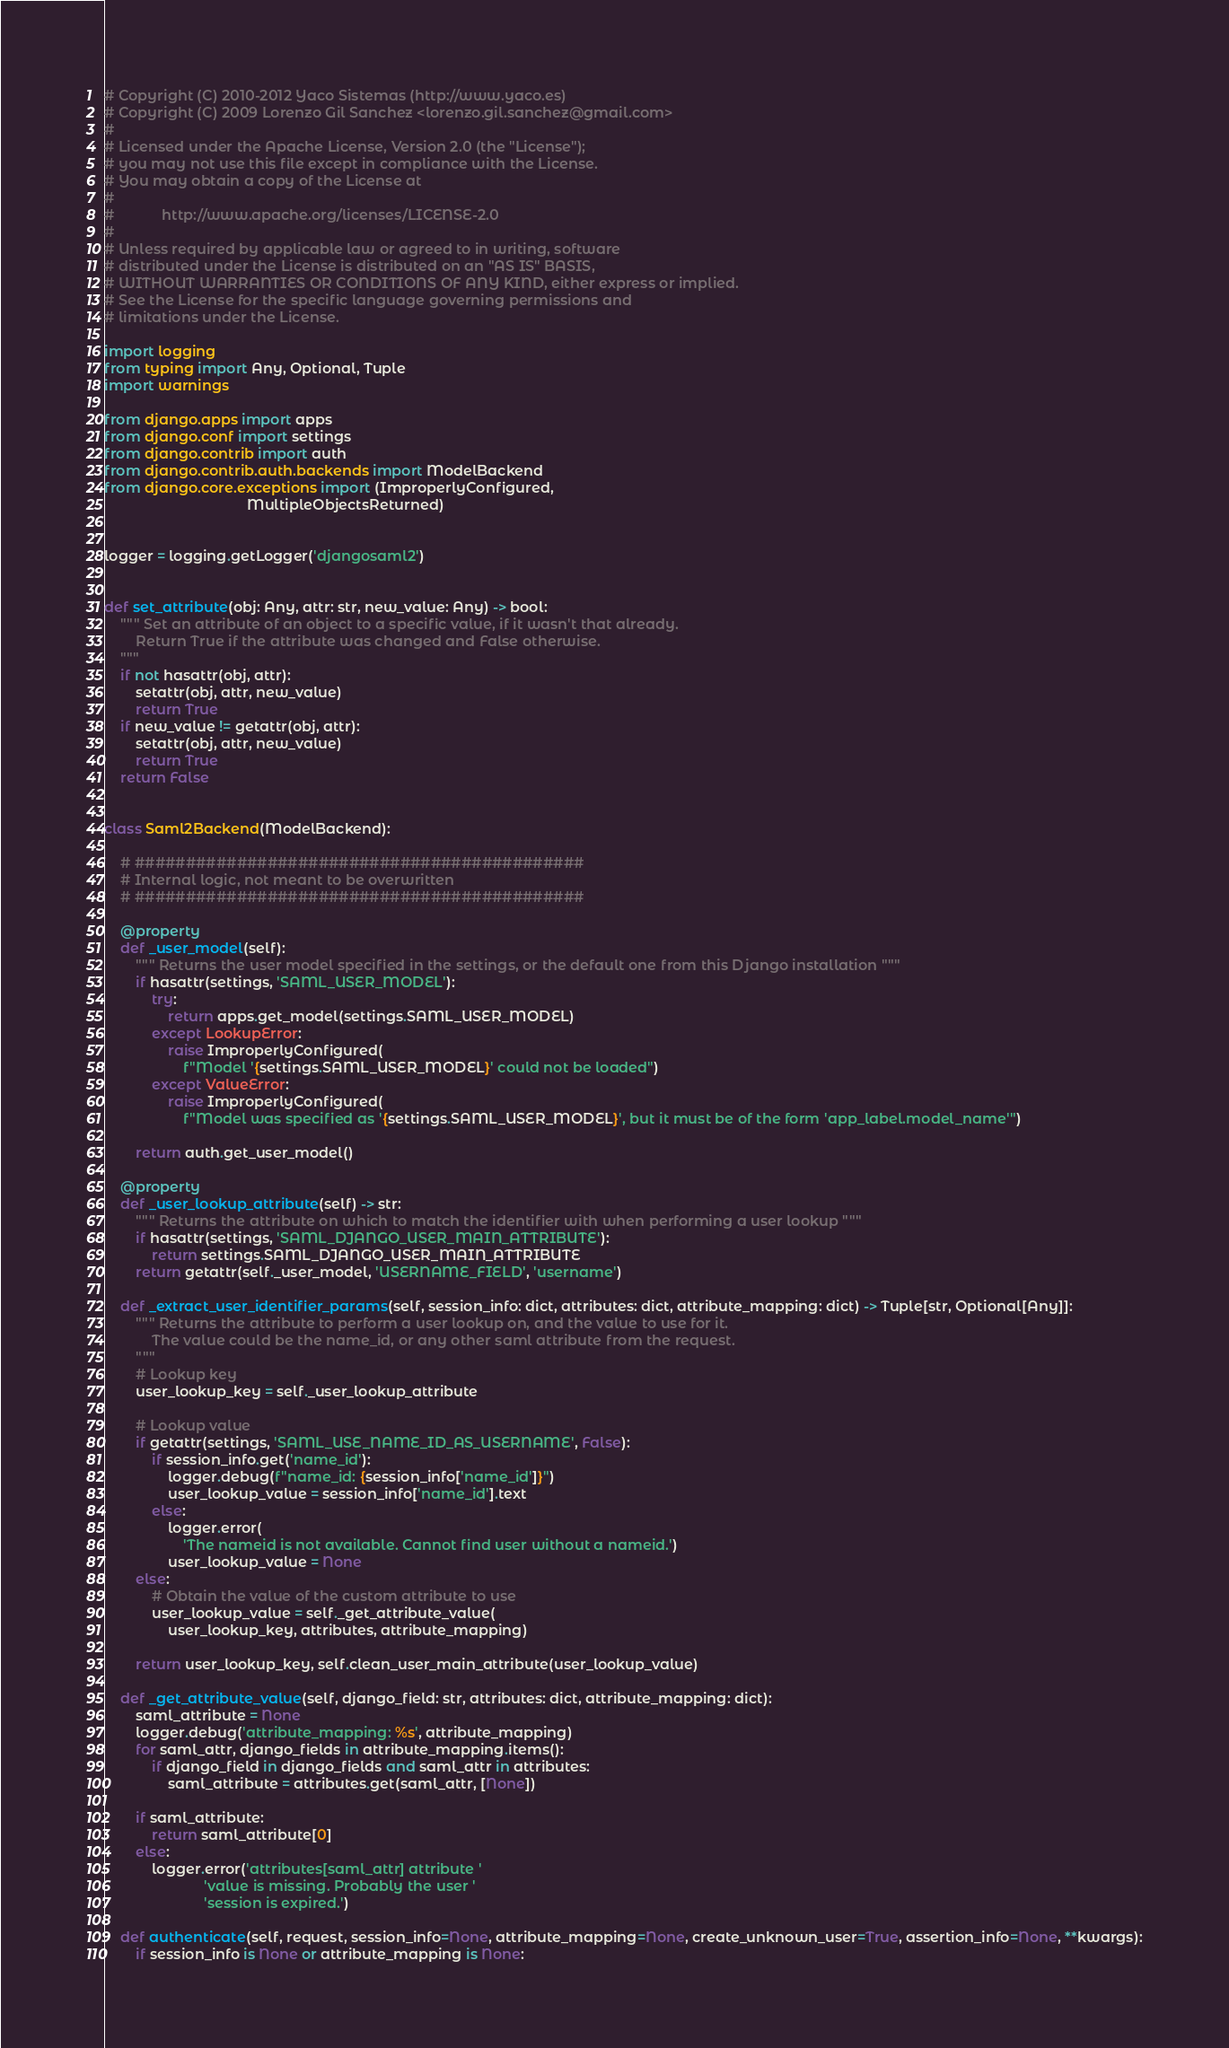Convert code to text. <code><loc_0><loc_0><loc_500><loc_500><_Python_># Copyright (C) 2010-2012 Yaco Sistemas (http://www.yaco.es)
# Copyright (C) 2009 Lorenzo Gil Sanchez <lorenzo.gil.sanchez@gmail.com>
#
# Licensed under the Apache License, Version 2.0 (the "License");
# you may not use this file except in compliance with the License.
# You may obtain a copy of the License at
#
#            http://www.apache.org/licenses/LICENSE-2.0
#
# Unless required by applicable law or agreed to in writing, software
# distributed under the License is distributed on an "AS IS" BASIS,
# WITHOUT WARRANTIES OR CONDITIONS OF ANY KIND, either express or implied.
# See the License for the specific language governing permissions and
# limitations under the License.

import logging
from typing import Any, Optional, Tuple
import warnings

from django.apps import apps
from django.conf import settings
from django.contrib import auth
from django.contrib.auth.backends import ModelBackend
from django.core.exceptions import (ImproperlyConfigured,
                                    MultipleObjectsReturned)


logger = logging.getLogger('djangosaml2')


def set_attribute(obj: Any, attr: str, new_value: Any) -> bool:
    """ Set an attribute of an object to a specific value, if it wasn't that already.
        Return True if the attribute was changed and False otherwise.
    """
    if not hasattr(obj, attr):
        setattr(obj, attr, new_value)
        return True
    if new_value != getattr(obj, attr):
        setattr(obj, attr, new_value)
        return True
    return False


class Saml2Backend(ModelBackend):

    # ############################################
    # Internal logic, not meant to be overwritten
    # ############################################

    @property
    def _user_model(self):
        """ Returns the user model specified in the settings, or the default one from this Django installation """
        if hasattr(settings, 'SAML_USER_MODEL'):
            try:
                return apps.get_model(settings.SAML_USER_MODEL)
            except LookupError:
                raise ImproperlyConfigured(
                    f"Model '{settings.SAML_USER_MODEL}' could not be loaded")
            except ValueError:
                raise ImproperlyConfigured(
                    f"Model was specified as '{settings.SAML_USER_MODEL}', but it must be of the form 'app_label.model_name'")

        return auth.get_user_model()

    @property
    def _user_lookup_attribute(self) -> str:
        """ Returns the attribute on which to match the identifier with when performing a user lookup """
        if hasattr(settings, 'SAML_DJANGO_USER_MAIN_ATTRIBUTE'):
            return settings.SAML_DJANGO_USER_MAIN_ATTRIBUTE
        return getattr(self._user_model, 'USERNAME_FIELD', 'username')

    def _extract_user_identifier_params(self, session_info: dict, attributes: dict, attribute_mapping: dict) -> Tuple[str, Optional[Any]]:
        """ Returns the attribute to perform a user lookup on, and the value to use for it.
            The value could be the name_id, or any other saml attribute from the request.
        """
        # Lookup key
        user_lookup_key = self._user_lookup_attribute

        # Lookup value
        if getattr(settings, 'SAML_USE_NAME_ID_AS_USERNAME', False):
            if session_info.get('name_id'):
                logger.debug(f"name_id: {session_info['name_id']}")
                user_lookup_value = session_info['name_id'].text
            else:
                logger.error(
                    'The nameid is not available. Cannot find user without a nameid.')
                user_lookup_value = None
        else:
            # Obtain the value of the custom attribute to use
            user_lookup_value = self._get_attribute_value(
                user_lookup_key, attributes, attribute_mapping)

        return user_lookup_key, self.clean_user_main_attribute(user_lookup_value)

    def _get_attribute_value(self, django_field: str, attributes: dict, attribute_mapping: dict):
        saml_attribute = None
        logger.debug('attribute_mapping: %s', attribute_mapping)
        for saml_attr, django_fields in attribute_mapping.items():
            if django_field in django_fields and saml_attr in attributes:
                saml_attribute = attributes.get(saml_attr, [None])

        if saml_attribute:
            return saml_attribute[0]
        else:
            logger.error('attributes[saml_attr] attribute '
                         'value is missing. Probably the user '
                         'session is expired.')

    def authenticate(self, request, session_info=None, attribute_mapping=None, create_unknown_user=True, assertion_info=None, **kwargs):
        if session_info is None or attribute_mapping is None:</code> 